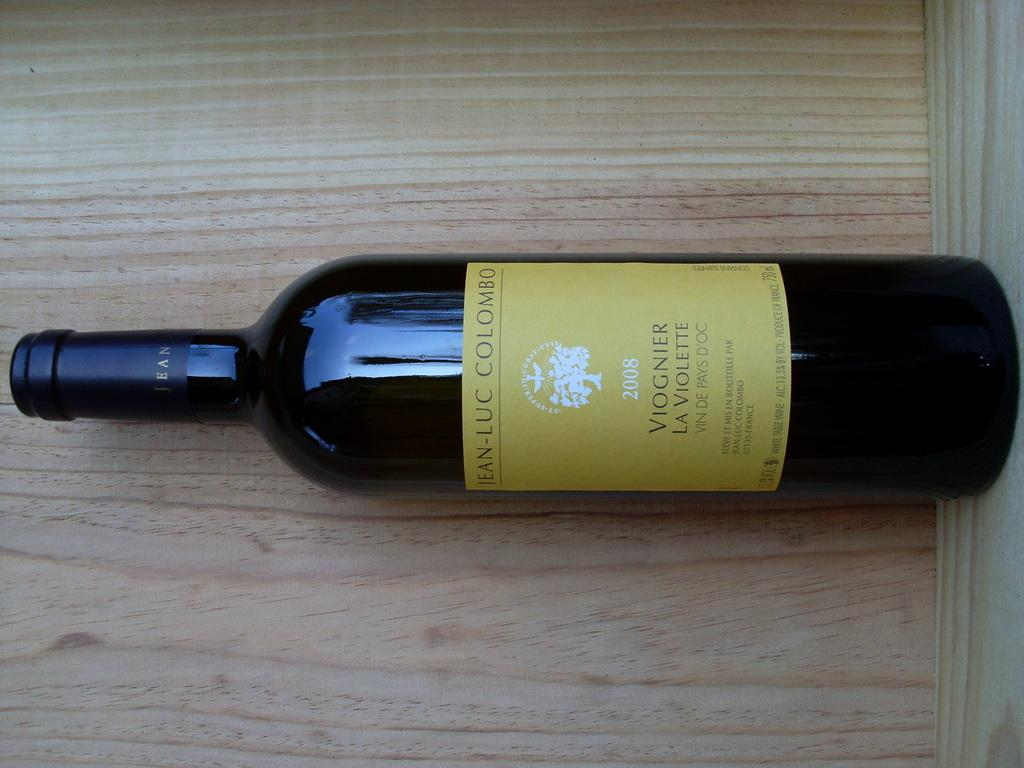<image>
Write a terse but informative summary of the picture. mustard yellow color label that says Jean-Luc Colombo and 2008. 